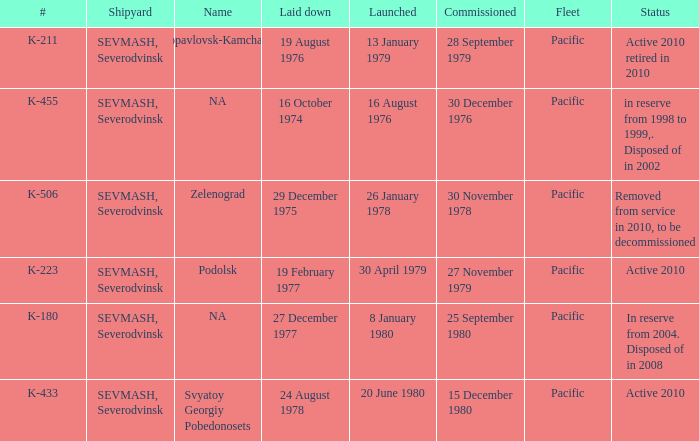Can you provide an update on the state of boat k-223? Active 2010. I'm looking to parse the entire table for insights. Could you assist me with that? {'header': ['#', 'Shipyard', 'Name', 'Laid down', 'Launched', 'Commissioned', 'Fleet', 'Status'], 'rows': [['K-211', 'SEVMASH, Severodvinsk', 'Petropavlovsk-Kamchatskiy', '19 August 1976', '13 January 1979', '28 September 1979', 'Pacific', 'Active 2010 retired in 2010'], ['K-455', 'SEVMASH, Severodvinsk', 'NA', '16 October 1974', '16 August 1976', '30 December 1976', 'Pacific', 'in reserve from 1998 to 1999,. Disposed of in 2002'], ['K-506', 'SEVMASH, Severodvinsk', 'Zelenograd', '29 December 1975', '26 January 1978', '30 November 1978', 'Pacific', 'Removed from service in 2010, to be decommissioned'], ['K-223', 'SEVMASH, Severodvinsk', 'Podolsk', '19 February 1977', '30 April 1979', '27 November 1979', 'Pacific', 'Active 2010'], ['K-180', 'SEVMASH, Severodvinsk', 'NA', '27 December 1977', '8 January 1980', '25 September 1980', 'Pacific', 'In reserve from 2004. Disposed of in 2008'], ['K-433', 'SEVMASH, Severodvinsk', 'Svyatoy Georgiy Pobedonosets', '24 August 1978', '20 June 1980', '15 December 1980', 'Pacific', 'Active 2010']]} 